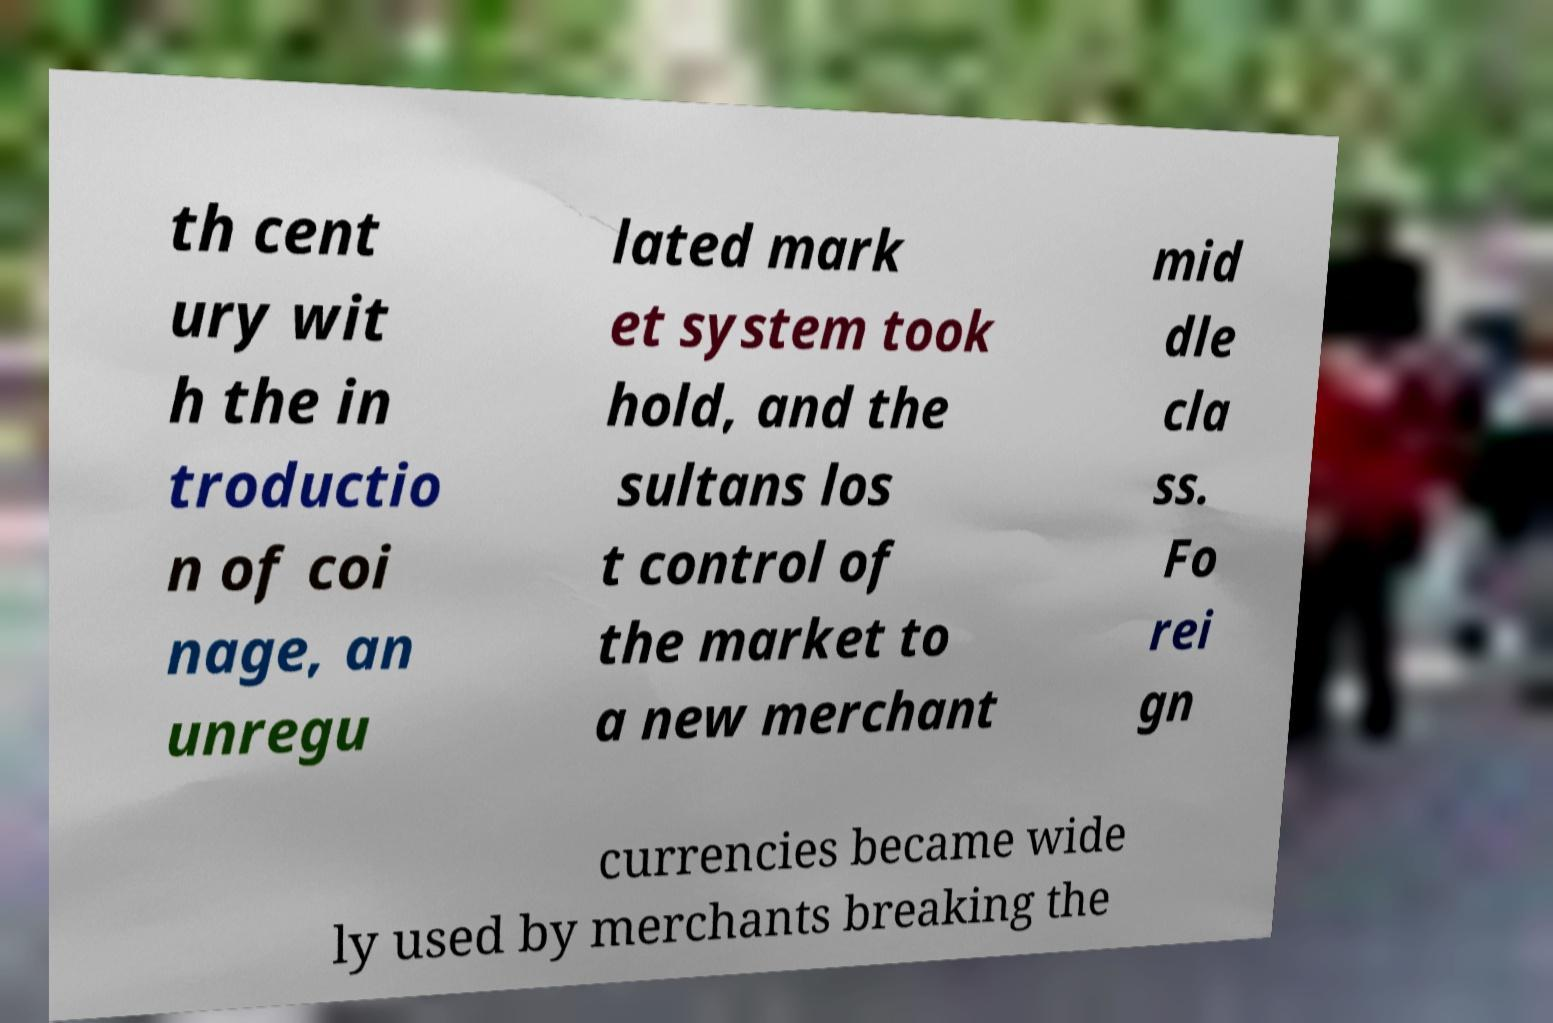Could you extract and type out the text from this image? th cent ury wit h the in troductio n of coi nage, an unregu lated mark et system took hold, and the sultans los t control of the market to a new merchant mid dle cla ss. Fo rei gn currencies became wide ly used by merchants breaking the 